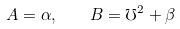<formula> <loc_0><loc_0><loc_500><loc_500>A = \alpha , \quad B = \mho ^ { 2 } + \beta</formula> 